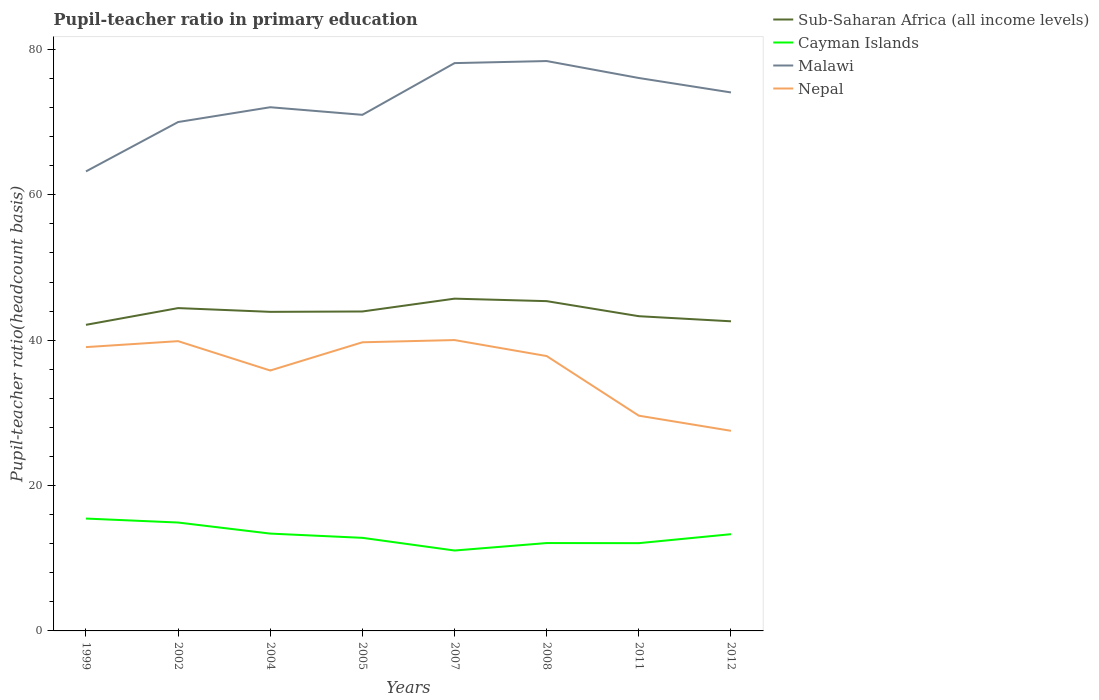Across all years, what is the maximum pupil-teacher ratio in primary education in Cayman Islands?
Give a very brief answer. 11.06. What is the total pupil-teacher ratio in primary education in Cayman Islands in the graph?
Give a very brief answer. -1.22. What is the difference between the highest and the second highest pupil-teacher ratio in primary education in Malawi?
Your answer should be compact. 15.18. How many years are there in the graph?
Keep it short and to the point. 8. What is the difference between two consecutive major ticks on the Y-axis?
Give a very brief answer. 20. Does the graph contain grids?
Make the answer very short. No. Where does the legend appear in the graph?
Give a very brief answer. Top right. What is the title of the graph?
Offer a very short reply. Pupil-teacher ratio in primary education. What is the label or title of the Y-axis?
Your answer should be compact. Pupil-teacher ratio(headcount basis). What is the Pupil-teacher ratio(headcount basis) in Sub-Saharan Africa (all income levels) in 1999?
Give a very brief answer. 42.11. What is the Pupil-teacher ratio(headcount basis) of Cayman Islands in 1999?
Make the answer very short. 15.46. What is the Pupil-teacher ratio(headcount basis) in Malawi in 1999?
Offer a terse response. 63.22. What is the Pupil-teacher ratio(headcount basis) in Nepal in 1999?
Offer a very short reply. 39.05. What is the Pupil-teacher ratio(headcount basis) of Sub-Saharan Africa (all income levels) in 2002?
Offer a terse response. 44.42. What is the Pupil-teacher ratio(headcount basis) of Cayman Islands in 2002?
Offer a very short reply. 14.91. What is the Pupil-teacher ratio(headcount basis) of Malawi in 2002?
Offer a terse response. 70.01. What is the Pupil-teacher ratio(headcount basis) of Nepal in 2002?
Your response must be concise. 39.87. What is the Pupil-teacher ratio(headcount basis) of Sub-Saharan Africa (all income levels) in 2004?
Provide a short and direct response. 43.9. What is the Pupil-teacher ratio(headcount basis) of Cayman Islands in 2004?
Offer a terse response. 13.39. What is the Pupil-teacher ratio(headcount basis) in Malawi in 2004?
Offer a terse response. 72.05. What is the Pupil-teacher ratio(headcount basis) in Nepal in 2004?
Your answer should be compact. 35.83. What is the Pupil-teacher ratio(headcount basis) of Sub-Saharan Africa (all income levels) in 2005?
Give a very brief answer. 43.95. What is the Pupil-teacher ratio(headcount basis) of Cayman Islands in 2005?
Offer a terse response. 12.81. What is the Pupil-teacher ratio(headcount basis) of Malawi in 2005?
Your answer should be very brief. 71.01. What is the Pupil-teacher ratio(headcount basis) of Nepal in 2005?
Provide a succinct answer. 39.71. What is the Pupil-teacher ratio(headcount basis) in Sub-Saharan Africa (all income levels) in 2007?
Offer a very short reply. 45.72. What is the Pupil-teacher ratio(headcount basis) in Cayman Islands in 2007?
Provide a succinct answer. 11.06. What is the Pupil-teacher ratio(headcount basis) of Malawi in 2007?
Give a very brief answer. 78.12. What is the Pupil-teacher ratio(headcount basis) in Nepal in 2007?
Give a very brief answer. 40.02. What is the Pupil-teacher ratio(headcount basis) of Sub-Saharan Africa (all income levels) in 2008?
Your answer should be compact. 45.37. What is the Pupil-teacher ratio(headcount basis) in Cayman Islands in 2008?
Keep it short and to the point. 12.09. What is the Pupil-teacher ratio(headcount basis) of Malawi in 2008?
Your answer should be compact. 78.41. What is the Pupil-teacher ratio(headcount basis) of Nepal in 2008?
Offer a terse response. 37.82. What is the Pupil-teacher ratio(headcount basis) of Sub-Saharan Africa (all income levels) in 2011?
Your answer should be very brief. 43.3. What is the Pupil-teacher ratio(headcount basis) in Cayman Islands in 2011?
Keep it short and to the point. 12.08. What is the Pupil-teacher ratio(headcount basis) of Malawi in 2011?
Your answer should be very brief. 76.07. What is the Pupil-teacher ratio(headcount basis) in Nepal in 2011?
Offer a terse response. 29.61. What is the Pupil-teacher ratio(headcount basis) of Sub-Saharan Africa (all income levels) in 2012?
Your answer should be very brief. 42.6. What is the Pupil-teacher ratio(headcount basis) of Cayman Islands in 2012?
Your answer should be compact. 13.31. What is the Pupil-teacher ratio(headcount basis) in Malawi in 2012?
Your answer should be very brief. 74.09. What is the Pupil-teacher ratio(headcount basis) of Nepal in 2012?
Make the answer very short. 27.53. Across all years, what is the maximum Pupil-teacher ratio(headcount basis) in Sub-Saharan Africa (all income levels)?
Ensure brevity in your answer.  45.72. Across all years, what is the maximum Pupil-teacher ratio(headcount basis) of Cayman Islands?
Offer a very short reply. 15.46. Across all years, what is the maximum Pupil-teacher ratio(headcount basis) of Malawi?
Offer a very short reply. 78.41. Across all years, what is the maximum Pupil-teacher ratio(headcount basis) in Nepal?
Keep it short and to the point. 40.02. Across all years, what is the minimum Pupil-teacher ratio(headcount basis) of Sub-Saharan Africa (all income levels)?
Provide a short and direct response. 42.11. Across all years, what is the minimum Pupil-teacher ratio(headcount basis) in Cayman Islands?
Offer a terse response. 11.06. Across all years, what is the minimum Pupil-teacher ratio(headcount basis) of Malawi?
Your response must be concise. 63.22. Across all years, what is the minimum Pupil-teacher ratio(headcount basis) of Nepal?
Your answer should be very brief. 27.53. What is the total Pupil-teacher ratio(headcount basis) in Sub-Saharan Africa (all income levels) in the graph?
Offer a very short reply. 351.37. What is the total Pupil-teacher ratio(headcount basis) of Cayman Islands in the graph?
Ensure brevity in your answer.  105.11. What is the total Pupil-teacher ratio(headcount basis) in Malawi in the graph?
Offer a very short reply. 582.98. What is the total Pupil-teacher ratio(headcount basis) of Nepal in the graph?
Your answer should be compact. 289.44. What is the difference between the Pupil-teacher ratio(headcount basis) in Sub-Saharan Africa (all income levels) in 1999 and that in 2002?
Your answer should be very brief. -2.3. What is the difference between the Pupil-teacher ratio(headcount basis) of Cayman Islands in 1999 and that in 2002?
Keep it short and to the point. 0.55. What is the difference between the Pupil-teacher ratio(headcount basis) in Malawi in 1999 and that in 2002?
Give a very brief answer. -6.79. What is the difference between the Pupil-teacher ratio(headcount basis) of Nepal in 1999 and that in 2002?
Make the answer very short. -0.82. What is the difference between the Pupil-teacher ratio(headcount basis) in Sub-Saharan Africa (all income levels) in 1999 and that in 2004?
Ensure brevity in your answer.  -1.79. What is the difference between the Pupil-teacher ratio(headcount basis) of Cayman Islands in 1999 and that in 2004?
Keep it short and to the point. 2.07. What is the difference between the Pupil-teacher ratio(headcount basis) in Malawi in 1999 and that in 2004?
Offer a very short reply. -8.83. What is the difference between the Pupil-teacher ratio(headcount basis) in Nepal in 1999 and that in 2004?
Your answer should be very brief. 3.22. What is the difference between the Pupil-teacher ratio(headcount basis) of Sub-Saharan Africa (all income levels) in 1999 and that in 2005?
Make the answer very short. -1.84. What is the difference between the Pupil-teacher ratio(headcount basis) in Cayman Islands in 1999 and that in 2005?
Ensure brevity in your answer.  2.65. What is the difference between the Pupil-teacher ratio(headcount basis) in Malawi in 1999 and that in 2005?
Give a very brief answer. -7.79. What is the difference between the Pupil-teacher ratio(headcount basis) in Nepal in 1999 and that in 2005?
Provide a short and direct response. -0.66. What is the difference between the Pupil-teacher ratio(headcount basis) of Sub-Saharan Africa (all income levels) in 1999 and that in 2007?
Your response must be concise. -3.6. What is the difference between the Pupil-teacher ratio(headcount basis) of Cayman Islands in 1999 and that in 2007?
Provide a short and direct response. 4.4. What is the difference between the Pupil-teacher ratio(headcount basis) of Malawi in 1999 and that in 2007?
Provide a succinct answer. -14.9. What is the difference between the Pupil-teacher ratio(headcount basis) of Nepal in 1999 and that in 2007?
Your answer should be very brief. -0.97. What is the difference between the Pupil-teacher ratio(headcount basis) of Sub-Saharan Africa (all income levels) in 1999 and that in 2008?
Offer a very short reply. -3.26. What is the difference between the Pupil-teacher ratio(headcount basis) of Cayman Islands in 1999 and that in 2008?
Offer a terse response. 3.37. What is the difference between the Pupil-teacher ratio(headcount basis) of Malawi in 1999 and that in 2008?
Your response must be concise. -15.18. What is the difference between the Pupil-teacher ratio(headcount basis) of Nepal in 1999 and that in 2008?
Offer a terse response. 1.23. What is the difference between the Pupil-teacher ratio(headcount basis) of Sub-Saharan Africa (all income levels) in 1999 and that in 2011?
Your response must be concise. -1.19. What is the difference between the Pupil-teacher ratio(headcount basis) of Cayman Islands in 1999 and that in 2011?
Offer a terse response. 3.38. What is the difference between the Pupil-teacher ratio(headcount basis) in Malawi in 1999 and that in 2011?
Give a very brief answer. -12.85. What is the difference between the Pupil-teacher ratio(headcount basis) in Nepal in 1999 and that in 2011?
Provide a succinct answer. 9.43. What is the difference between the Pupil-teacher ratio(headcount basis) in Sub-Saharan Africa (all income levels) in 1999 and that in 2012?
Offer a very short reply. -0.48. What is the difference between the Pupil-teacher ratio(headcount basis) in Cayman Islands in 1999 and that in 2012?
Provide a short and direct response. 2.15. What is the difference between the Pupil-teacher ratio(headcount basis) of Malawi in 1999 and that in 2012?
Keep it short and to the point. -10.86. What is the difference between the Pupil-teacher ratio(headcount basis) of Nepal in 1999 and that in 2012?
Give a very brief answer. 11.52. What is the difference between the Pupil-teacher ratio(headcount basis) of Sub-Saharan Africa (all income levels) in 2002 and that in 2004?
Your response must be concise. 0.52. What is the difference between the Pupil-teacher ratio(headcount basis) in Cayman Islands in 2002 and that in 2004?
Provide a short and direct response. 1.52. What is the difference between the Pupil-teacher ratio(headcount basis) of Malawi in 2002 and that in 2004?
Offer a very short reply. -2.04. What is the difference between the Pupil-teacher ratio(headcount basis) in Nepal in 2002 and that in 2004?
Provide a succinct answer. 4.04. What is the difference between the Pupil-teacher ratio(headcount basis) of Sub-Saharan Africa (all income levels) in 2002 and that in 2005?
Ensure brevity in your answer.  0.47. What is the difference between the Pupil-teacher ratio(headcount basis) of Cayman Islands in 2002 and that in 2005?
Your answer should be compact. 2.11. What is the difference between the Pupil-teacher ratio(headcount basis) of Malawi in 2002 and that in 2005?
Offer a terse response. -0.99. What is the difference between the Pupil-teacher ratio(headcount basis) of Nepal in 2002 and that in 2005?
Keep it short and to the point. 0.16. What is the difference between the Pupil-teacher ratio(headcount basis) of Sub-Saharan Africa (all income levels) in 2002 and that in 2007?
Ensure brevity in your answer.  -1.3. What is the difference between the Pupil-teacher ratio(headcount basis) of Cayman Islands in 2002 and that in 2007?
Your answer should be very brief. 3.85. What is the difference between the Pupil-teacher ratio(headcount basis) of Malawi in 2002 and that in 2007?
Your answer should be compact. -8.11. What is the difference between the Pupil-teacher ratio(headcount basis) of Nepal in 2002 and that in 2007?
Make the answer very short. -0.15. What is the difference between the Pupil-teacher ratio(headcount basis) in Sub-Saharan Africa (all income levels) in 2002 and that in 2008?
Your answer should be compact. -0.96. What is the difference between the Pupil-teacher ratio(headcount basis) in Cayman Islands in 2002 and that in 2008?
Ensure brevity in your answer.  2.82. What is the difference between the Pupil-teacher ratio(headcount basis) of Malawi in 2002 and that in 2008?
Your response must be concise. -8.39. What is the difference between the Pupil-teacher ratio(headcount basis) in Nepal in 2002 and that in 2008?
Your answer should be compact. 2.05. What is the difference between the Pupil-teacher ratio(headcount basis) in Sub-Saharan Africa (all income levels) in 2002 and that in 2011?
Make the answer very short. 1.12. What is the difference between the Pupil-teacher ratio(headcount basis) in Cayman Islands in 2002 and that in 2011?
Offer a very short reply. 2.84. What is the difference between the Pupil-teacher ratio(headcount basis) of Malawi in 2002 and that in 2011?
Your answer should be very brief. -6.06. What is the difference between the Pupil-teacher ratio(headcount basis) of Nepal in 2002 and that in 2011?
Offer a terse response. 10.25. What is the difference between the Pupil-teacher ratio(headcount basis) in Sub-Saharan Africa (all income levels) in 2002 and that in 2012?
Your answer should be very brief. 1.82. What is the difference between the Pupil-teacher ratio(headcount basis) in Cayman Islands in 2002 and that in 2012?
Your response must be concise. 1.6. What is the difference between the Pupil-teacher ratio(headcount basis) of Malawi in 2002 and that in 2012?
Keep it short and to the point. -4.07. What is the difference between the Pupil-teacher ratio(headcount basis) in Nepal in 2002 and that in 2012?
Your answer should be very brief. 12.34. What is the difference between the Pupil-teacher ratio(headcount basis) of Sub-Saharan Africa (all income levels) in 2004 and that in 2005?
Your answer should be very brief. -0.05. What is the difference between the Pupil-teacher ratio(headcount basis) of Cayman Islands in 2004 and that in 2005?
Provide a succinct answer. 0.58. What is the difference between the Pupil-teacher ratio(headcount basis) of Malawi in 2004 and that in 2005?
Provide a short and direct response. 1.04. What is the difference between the Pupil-teacher ratio(headcount basis) in Nepal in 2004 and that in 2005?
Offer a terse response. -3.88. What is the difference between the Pupil-teacher ratio(headcount basis) in Sub-Saharan Africa (all income levels) in 2004 and that in 2007?
Ensure brevity in your answer.  -1.81. What is the difference between the Pupil-teacher ratio(headcount basis) of Cayman Islands in 2004 and that in 2007?
Your response must be concise. 2.33. What is the difference between the Pupil-teacher ratio(headcount basis) of Malawi in 2004 and that in 2007?
Provide a short and direct response. -6.07. What is the difference between the Pupil-teacher ratio(headcount basis) of Nepal in 2004 and that in 2007?
Your response must be concise. -4.19. What is the difference between the Pupil-teacher ratio(headcount basis) in Sub-Saharan Africa (all income levels) in 2004 and that in 2008?
Ensure brevity in your answer.  -1.47. What is the difference between the Pupil-teacher ratio(headcount basis) of Cayman Islands in 2004 and that in 2008?
Provide a succinct answer. 1.3. What is the difference between the Pupil-teacher ratio(headcount basis) in Malawi in 2004 and that in 2008?
Offer a terse response. -6.35. What is the difference between the Pupil-teacher ratio(headcount basis) in Nepal in 2004 and that in 2008?
Make the answer very short. -1.99. What is the difference between the Pupil-teacher ratio(headcount basis) in Sub-Saharan Africa (all income levels) in 2004 and that in 2011?
Your answer should be very brief. 0.6. What is the difference between the Pupil-teacher ratio(headcount basis) in Cayman Islands in 2004 and that in 2011?
Make the answer very short. 1.31. What is the difference between the Pupil-teacher ratio(headcount basis) in Malawi in 2004 and that in 2011?
Offer a very short reply. -4.02. What is the difference between the Pupil-teacher ratio(headcount basis) of Nepal in 2004 and that in 2011?
Keep it short and to the point. 6.21. What is the difference between the Pupil-teacher ratio(headcount basis) of Sub-Saharan Africa (all income levels) in 2004 and that in 2012?
Your answer should be compact. 1.3. What is the difference between the Pupil-teacher ratio(headcount basis) in Cayman Islands in 2004 and that in 2012?
Provide a short and direct response. 0.08. What is the difference between the Pupil-teacher ratio(headcount basis) in Malawi in 2004 and that in 2012?
Your response must be concise. -2.03. What is the difference between the Pupil-teacher ratio(headcount basis) of Nepal in 2004 and that in 2012?
Give a very brief answer. 8.3. What is the difference between the Pupil-teacher ratio(headcount basis) in Sub-Saharan Africa (all income levels) in 2005 and that in 2007?
Make the answer very short. -1.76. What is the difference between the Pupil-teacher ratio(headcount basis) in Cayman Islands in 2005 and that in 2007?
Offer a very short reply. 1.74. What is the difference between the Pupil-teacher ratio(headcount basis) in Malawi in 2005 and that in 2007?
Your answer should be very brief. -7.12. What is the difference between the Pupil-teacher ratio(headcount basis) in Nepal in 2005 and that in 2007?
Make the answer very short. -0.31. What is the difference between the Pupil-teacher ratio(headcount basis) in Sub-Saharan Africa (all income levels) in 2005 and that in 2008?
Your response must be concise. -1.42. What is the difference between the Pupil-teacher ratio(headcount basis) in Cayman Islands in 2005 and that in 2008?
Keep it short and to the point. 0.72. What is the difference between the Pupil-teacher ratio(headcount basis) of Malawi in 2005 and that in 2008?
Keep it short and to the point. -7.4. What is the difference between the Pupil-teacher ratio(headcount basis) of Nepal in 2005 and that in 2008?
Offer a terse response. 1.9. What is the difference between the Pupil-teacher ratio(headcount basis) in Sub-Saharan Africa (all income levels) in 2005 and that in 2011?
Offer a terse response. 0.65. What is the difference between the Pupil-teacher ratio(headcount basis) of Cayman Islands in 2005 and that in 2011?
Ensure brevity in your answer.  0.73. What is the difference between the Pupil-teacher ratio(headcount basis) in Malawi in 2005 and that in 2011?
Your response must be concise. -5.07. What is the difference between the Pupil-teacher ratio(headcount basis) of Nepal in 2005 and that in 2011?
Your answer should be very brief. 10.1. What is the difference between the Pupil-teacher ratio(headcount basis) of Sub-Saharan Africa (all income levels) in 2005 and that in 2012?
Give a very brief answer. 1.35. What is the difference between the Pupil-teacher ratio(headcount basis) of Cayman Islands in 2005 and that in 2012?
Your answer should be very brief. -0.5. What is the difference between the Pupil-teacher ratio(headcount basis) in Malawi in 2005 and that in 2012?
Make the answer very short. -3.08. What is the difference between the Pupil-teacher ratio(headcount basis) in Nepal in 2005 and that in 2012?
Offer a terse response. 12.18. What is the difference between the Pupil-teacher ratio(headcount basis) of Sub-Saharan Africa (all income levels) in 2007 and that in 2008?
Provide a succinct answer. 0.34. What is the difference between the Pupil-teacher ratio(headcount basis) in Cayman Islands in 2007 and that in 2008?
Offer a terse response. -1.03. What is the difference between the Pupil-teacher ratio(headcount basis) in Malawi in 2007 and that in 2008?
Ensure brevity in your answer.  -0.28. What is the difference between the Pupil-teacher ratio(headcount basis) in Nepal in 2007 and that in 2008?
Give a very brief answer. 2.2. What is the difference between the Pupil-teacher ratio(headcount basis) in Sub-Saharan Africa (all income levels) in 2007 and that in 2011?
Provide a short and direct response. 2.41. What is the difference between the Pupil-teacher ratio(headcount basis) of Cayman Islands in 2007 and that in 2011?
Offer a very short reply. -1.01. What is the difference between the Pupil-teacher ratio(headcount basis) in Malawi in 2007 and that in 2011?
Keep it short and to the point. 2.05. What is the difference between the Pupil-teacher ratio(headcount basis) in Nepal in 2007 and that in 2011?
Provide a succinct answer. 10.4. What is the difference between the Pupil-teacher ratio(headcount basis) in Sub-Saharan Africa (all income levels) in 2007 and that in 2012?
Give a very brief answer. 3.12. What is the difference between the Pupil-teacher ratio(headcount basis) of Cayman Islands in 2007 and that in 2012?
Make the answer very short. -2.25. What is the difference between the Pupil-teacher ratio(headcount basis) of Malawi in 2007 and that in 2012?
Keep it short and to the point. 4.04. What is the difference between the Pupil-teacher ratio(headcount basis) in Nepal in 2007 and that in 2012?
Your answer should be very brief. 12.48. What is the difference between the Pupil-teacher ratio(headcount basis) in Sub-Saharan Africa (all income levels) in 2008 and that in 2011?
Keep it short and to the point. 2.07. What is the difference between the Pupil-teacher ratio(headcount basis) of Cayman Islands in 2008 and that in 2011?
Ensure brevity in your answer.  0.01. What is the difference between the Pupil-teacher ratio(headcount basis) in Malawi in 2008 and that in 2011?
Your answer should be very brief. 2.33. What is the difference between the Pupil-teacher ratio(headcount basis) of Nepal in 2008 and that in 2011?
Offer a very short reply. 8.2. What is the difference between the Pupil-teacher ratio(headcount basis) of Sub-Saharan Africa (all income levels) in 2008 and that in 2012?
Your answer should be very brief. 2.77. What is the difference between the Pupil-teacher ratio(headcount basis) of Cayman Islands in 2008 and that in 2012?
Make the answer very short. -1.22. What is the difference between the Pupil-teacher ratio(headcount basis) of Malawi in 2008 and that in 2012?
Your response must be concise. 4.32. What is the difference between the Pupil-teacher ratio(headcount basis) of Nepal in 2008 and that in 2012?
Your answer should be compact. 10.28. What is the difference between the Pupil-teacher ratio(headcount basis) of Sub-Saharan Africa (all income levels) in 2011 and that in 2012?
Give a very brief answer. 0.7. What is the difference between the Pupil-teacher ratio(headcount basis) in Cayman Islands in 2011 and that in 2012?
Your answer should be compact. -1.23. What is the difference between the Pupil-teacher ratio(headcount basis) of Malawi in 2011 and that in 2012?
Keep it short and to the point. 1.99. What is the difference between the Pupil-teacher ratio(headcount basis) of Nepal in 2011 and that in 2012?
Make the answer very short. 2.08. What is the difference between the Pupil-teacher ratio(headcount basis) of Sub-Saharan Africa (all income levels) in 1999 and the Pupil-teacher ratio(headcount basis) of Cayman Islands in 2002?
Keep it short and to the point. 27.2. What is the difference between the Pupil-teacher ratio(headcount basis) in Sub-Saharan Africa (all income levels) in 1999 and the Pupil-teacher ratio(headcount basis) in Malawi in 2002?
Make the answer very short. -27.9. What is the difference between the Pupil-teacher ratio(headcount basis) in Sub-Saharan Africa (all income levels) in 1999 and the Pupil-teacher ratio(headcount basis) in Nepal in 2002?
Provide a short and direct response. 2.25. What is the difference between the Pupil-teacher ratio(headcount basis) in Cayman Islands in 1999 and the Pupil-teacher ratio(headcount basis) in Malawi in 2002?
Offer a very short reply. -54.56. What is the difference between the Pupil-teacher ratio(headcount basis) in Cayman Islands in 1999 and the Pupil-teacher ratio(headcount basis) in Nepal in 2002?
Ensure brevity in your answer.  -24.41. What is the difference between the Pupil-teacher ratio(headcount basis) in Malawi in 1999 and the Pupil-teacher ratio(headcount basis) in Nepal in 2002?
Provide a short and direct response. 23.35. What is the difference between the Pupil-teacher ratio(headcount basis) of Sub-Saharan Africa (all income levels) in 1999 and the Pupil-teacher ratio(headcount basis) of Cayman Islands in 2004?
Keep it short and to the point. 28.72. What is the difference between the Pupil-teacher ratio(headcount basis) of Sub-Saharan Africa (all income levels) in 1999 and the Pupil-teacher ratio(headcount basis) of Malawi in 2004?
Your answer should be compact. -29.94. What is the difference between the Pupil-teacher ratio(headcount basis) of Sub-Saharan Africa (all income levels) in 1999 and the Pupil-teacher ratio(headcount basis) of Nepal in 2004?
Ensure brevity in your answer.  6.29. What is the difference between the Pupil-teacher ratio(headcount basis) in Cayman Islands in 1999 and the Pupil-teacher ratio(headcount basis) in Malawi in 2004?
Keep it short and to the point. -56.59. What is the difference between the Pupil-teacher ratio(headcount basis) of Cayman Islands in 1999 and the Pupil-teacher ratio(headcount basis) of Nepal in 2004?
Your answer should be very brief. -20.37. What is the difference between the Pupil-teacher ratio(headcount basis) of Malawi in 1999 and the Pupil-teacher ratio(headcount basis) of Nepal in 2004?
Give a very brief answer. 27.39. What is the difference between the Pupil-teacher ratio(headcount basis) in Sub-Saharan Africa (all income levels) in 1999 and the Pupil-teacher ratio(headcount basis) in Cayman Islands in 2005?
Your response must be concise. 29.31. What is the difference between the Pupil-teacher ratio(headcount basis) of Sub-Saharan Africa (all income levels) in 1999 and the Pupil-teacher ratio(headcount basis) of Malawi in 2005?
Your response must be concise. -28.89. What is the difference between the Pupil-teacher ratio(headcount basis) of Sub-Saharan Africa (all income levels) in 1999 and the Pupil-teacher ratio(headcount basis) of Nepal in 2005?
Provide a succinct answer. 2.4. What is the difference between the Pupil-teacher ratio(headcount basis) of Cayman Islands in 1999 and the Pupil-teacher ratio(headcount basis) of Malawi in 2005?
Offer a terse response. -55.55. What is the difference between the Pupil-teacher ratio(headcount basis) in Cayman Islands in 1999 and the Pupil-teacher ratio(headcount basis) in Nepal in 2005?
Provide a succinct answer. -24.25. What is the difference between the Pupil-teacher ratio(headcount basis) in Malawi in 1999 and the Pupil-teacher ratio(headcount basis) in Nepal in 2005?
Provide a short and direct response. 23.51. What is the difference between the Pupil-teacher ratio(headcount basis) of Sub-Saharan Africa (all income levels) in 1999 and the Pupil-teacher ratio(headcount basis) of Cayman Islands in 2007?
Provide a succinct answer. 31.05. What is the difference between the Pupil-teacher ratio(headcount basis) of Sub-Saharan Africa (all income levels) in 1999 and the Pupil-teacher ratio(headcount basis) of Malawi in 2007?
Give a very brief answer. -36.01. What is the difference between the Pupil-teacher ratio(headcount basis) in Sub-Saharan Africa (all income levels) in 1999 and the Pupil-teacher ratio(headcount basis) in Nepal in 2007?
Keep it short and to the point. 2.1. What is the difference between the Pupil-teacher ratio(headcount basis) in Cayman Islands in 1999 and the Pupil-teacher ratio(headcount basis) in Malawi in 2007?
Your response must be concise. -62.66. What is the difference between the Pupil-teacher ratio(headcount basis) of Cayman Islands in 1999 and the Pupil-teacher ratio(headcount basis) of Nepal in 2007?
Provide a succinct answer. -24.56. What is the difference between the Pupil-teacher ratio(headcount basis) in Malawi in 1999 and the Pupil-teacher ratio(headcount basis) in Nepal in 2007?
Keep it short and to the point. 23.2. What is the difference between the Pupil-teacher ratio(headcount basis) in Sub-Saharan Africa (all income levels) in 1999 and the Pupil-teacher ratio(headcount basis) in Cayman Islands in 2008?
Ensure brevity in your answer.  30.02. What is the difference between the Pupil-teacher ratio(headcount basis) in Sub-Saharan Africa (all income levels) in 1999 and the Pupil-teacher ratio(headcount basis) in Malawi in 2008?
Provide a short and direct response. -36.29. What is the difference between the Pupil-teacher ratio(headcount basis) of Sub-Saharan Africa (all income levels) in 1999 and the Pupil-teacher ratio(headcount basis) of Nepal in 2008?
Provide a short and direct response. 4.3. What is the difference between the Pupil-teacher ratio(headcount basis) in Cayman Islands in 1999 and the Pupil-teacher ratio(headcount basis) in Malawi in 2008?
Your answer should be compact. -62.95. What is the difference between the Pupil-teacher ratio(headcount basis) in Cayman Islands in 1999 and the Pupil-teacher ratio(headcount basis) in Nepal in 2008?
Provide a succinct answer. -22.36. What is the difference between the Pupil-teacher ratio(headcount basis) of Malawi in 1999 and the Pupil-teacher ratio(headcount basis) of Nepal in 2008?
Your answer should be very brief. 25.4. What is the difference between the Pupil-teacher ratio(headcount basis) in Sub-Saharan Africa (all income levels) in 1999 and the Pupil-teacher ratio(headcount basis) in Cayman Islands in 2011?
Your answer should be compact. 30.04. What is the difference between the Pupil-teacher ratio(headcount basis) in Sub-Saharan Africa (all income levels) in 1999 and the Pupil-teacher ratio(headcount basis) in Malawi in 2011?
Provide a succinct answer. -33.96. What is the difference between the Pupil-teacher ratio(headcount basis) of Sub-Saharan Africa (all income levels) in 1999 and the Pupil-teacher ratio(headcount basis) of Nepal in 2011?
Offer a very short reply. 12.5. What is the difference between the Pupil-teacher ratio(headcount basis) in Cayman Islands in 1999 and the Pupil-teacher ratio(headcount basis) in Malawi in 2011?
Provide a short and direct response. -60.61. What is the difference between the Pupil-teacher ratio(headcount basis) in Cayman Islands in 1999 and the Pupil-teacher ratio(headcount basis) in Nepal in 2011?
Ensure brevity in your answer.  -14.15. What is the difference between the Pupil-teacher ratio(headcount basis) in Malawi in 1999 and the Pupil-teacher ratio(headcount basis) in Nepal in 2011?
Your answer should be compact. 33.61. What is the difference between the Pupil-teacher ratio(headcount basis) in Sub-Saharan Africa (all income levels) in 1999 and the Pupil-teacher ratio(headcount basis) in Cayman Islands in 2012?
Offer a very short reply. 28.8. What is the difference between the Pupil-teacher ratio(headcount basis) in Sub-Saharan Africa (all income levels) in 1999 and the Pupil-teacher ratio(headcount basis) in Malawi in 2012?
Offer a terse response. -31.97. What is the difference between the Pupil-teacher ratio(headcount basis) of Sub-Saharan Africa (all income levels) in 1999 and the Pupil-teacher ratio(headcount basis) of Nepal in 2012?
Give a very brief answer. 14.58. What is the difference between the Pupil-teacher ratio(headcount basis) in Cayman Islands in 1999 and the Pupil-teacher ratio(headcount basis) in Malawi in 2012?
Provide a succinct answer. -58.63. What is the difference between the Pupil-teacher ratio(headcount basis) of Cayman Islands in 1999 and the Pupil-teacher ratio(headcount basis) of Nepal in 2012?
Offer a terse response. -12.07. What is the difference between the Pupil-teacher ratio(headcount basis) of Malawi in 1999 and the Pupil-teacher ratio(headcount basis) of Nepal in 2012?
Your response must be concise. 35.69. What is the difference between the Pupil-teacher ratio(headcount basis) of Sub-Saharan Africa (all income levels) in 2002 and the Pupil-teacher ratio(headcount basis) of Cayman Islands in 2004?
Your answer should be compact. 31.03. What is the difference between the Pupil-teacher ratio(headcount basis) in Sub-Saharan Africa (all income levels) in 2002 and the Pupil-teacher ratio(headcount basis) in Malawi in 2004?
Your response must be concise. -27.63. What is the difference between the Pupil-teacher ratio(headcount basis) of Sub-Saharan Africa (all income levels) in 2002 and the Pupil-teacher ratio(headcount basis) of Nepal in 2004?
Ensure brevity in your answer.  8.59. What is the difference between the Pupil-teacher ratio(headcount basis) of Cayman Islands in 2002 and the Pupil-teacher ratio(headcount basis) of Malawi in 2004?
Keep it short and to the point. -57.14. What is the difference between the Pupil-teacher ratio(headcount basis) in Cayman Islands in 2002 and the Pupil-teacher ratio(headcount basis) in Nepal in 2004?
Keep it short and to the point. -20.92. What is the difference between the Pupil-teacher ratio(headcount basis) in Malawi in 2002 and the Pupil-teacher ratio(headcount basis) in Nepal in 2004?
Give a very brief answer. 34.19. What is the difference between the Pupil-teacher ratio(headcount basis) of Sub-Saharan Africa (all income levels) in 2002 and the Pupil-teacher ratio(headcount basis) of Cayman Islands in 2005?
Give a very brief answer. 31.61. What is the difference between the Pupil-teacher ratio(headcount basis) in Sub-Saharan Africa (all income levels) in 2002 and the Pupil-teacher ratio(headcount basis) in Malawi in 2005?
Make the answer very short. -26.59. What is the difference between the Pupil-teacher ratio(headcount basis) in Sub-Saharan Africa (all income levels) in 2002 and the Pupil-teacher ratio(headcount basis) in Nepal in 2005?
Make the answer very short. 4.71. What is the difference between the Pupil-teacher ratio(headcount basis) in Cayman Islands in 2002 and the Pupil-teacher ratio(headcount basis) in Malawi in 2005?
Give a very brief answer. -56.09. What is the difference between the Pupil-teacher ratio(headcount basis) in Cayman Islands in 2002 and the Pupil-teacher ratio(headcount basis) in Nepal in 2005?
Your answer should be compact. -24.8. What is the difference between the Pupil-teacher ratio(headcount basis) of Malawi in 2002 and the Pupil-teacher ratio(headcount basis) of Nepal in 2005?
Keep it short and to the point. 30.3. What is the difference between the Pupil-teacher ratio(headcount basis) of Sub-Saharan Africa (all income levels) in 2002 and the Pupil-teacher ratio(headcount basis) of Cayman Islands in 2007?
Your answer should be very brief. 33.35. What is the difference between the Pupil-teacher ratio(headcount basis) of Sub-Saharan Africa (all income levels) in 2002 and the Pupil-teacher ratio(headcount basis) of Malawi in 2007?
Your answer should be very brief. -33.71. What is the difference between the Pupil-teacher ratio(headcount basis) in Sub-Saharan Africa (all income levels) in 2002 and the Pupil-teacher ratio(headcount basis) in Nepal in 2007?
Your response must be concise. 4.4. What is the difference between the Pupil-teacher ratio(headcount basis) in Cayman Islands in 2002 and the Pupil-teacher ratio(headcount basis) in Malawi in 2007?
Offer a very short reply. -63.21. What is the difference between the Pupil-teacher ratio(headcount basis) of Cayman Islands in 2002 and the Pupil-teacher ratio(headcount basis) of Nepal in 2007?
Ensure brevity in your answer.  -25.11. What is the difference between the Pupil-teacher ratio(headcount basis) in Malawi in 2002 and the Pupil-teacher ratio(headcount basis) in Nepal in 2007?
Give a very brief answer. 30. What is the difference between the Pupil-teacher ratio(headcount basis) of Sub-Saharan Africa (all income levels) in 2002 and the Pupil-teacher ratio(headcount basis) of Cayman Islands in 2008?
Your response must be concise. 32.33. What is the difference between the Pupil-teacher ratio(headcount basis) in Sub-Saharan Africa (all income levels) in 2002 and the Pupil-teacher ratio(headcount basis) in Malawi in 2008?
Your answer should be very brief. -33.99. What is the difference between the Pupil-teacher ratio(headcount basis) of Sub-Saharan Africa (all income levels) in 2002 and the Pupil-teacher ratio(headcount basis) of Nepal in 2008?
Provide a short and direct response. 6.6. What is the difference between the Pupil-teacher ratio(headcount basis) in Cayman Islands in 2002 and the Pupil-teacher ratio(headcount basis) in Malawi in 2008?
Make the answer very short. -63.49. What is the difference between the Pupil-teacher ratio(headcount basis) in Cayman Islands in 2002 and the Pupil-teacher ratio(headcount basis) in Nepal in 2008?
Offer a terse response. -22.9. What is the difference between the Pupil-teacher ratio(headcount basis) in Malawi in 2002 and the Pupil-teacher ratio(headcount basis) in Nepal in 2008?
Keep it short and to the point. 32.2. What is the difference between the Pupil-teacher ratio(headcount basis) in Sub-Saharan Africa (all income levels) in 2002 and the Pupil-teacher ratio(headcount basis) in Cayman Islands in 2011?
Give a very brief answer. 32.34. What is the difference between the Pupil-teacher ratio(headcount basis) of Sub-Saharan Africa (all income levels) in 2002 and the Pupil-teacher ratio(headcount basis) of Malawi in 2011?
Provide a succinct answer. -31.66. What is the difference between the Pupil-teacher ratio(headcount basis) of Sub-Saharan Africa (all income levels) in 2002 and the Pupil-teacher ratio(headcount basis) of Nepal in 2011?
Provide a succinct answer. 14.8. What is the difference between the Pupil-teacher ratio(headcount basis) of Cayman Islands in 2002 and the Pupil-teacher ratio(headcount basis) of Malawi in 2011?
Make the answer very short. -61.16. What is the difference between the Pupil-teacher ratio(headcount basis) of Cayman Islands in 2002 and the Pupil-teacher ratio(headcount basis) of Nepal in 2011?
Offer a very short reply. -14.7. What is the difference between the Pupil-teacher ratio(headcount basis) of Malawi in 2002 and the Pupil-teacher ratio(headcount basis) of Nepal in 2011?
Provide a succinct answer. 40.4. What is the difference between the Pupil-teacher ratio(headcount basis) of Sub-Saharan Africa (all income levels) in 2002 and the Pupil-teacher ratio(headcount basis) of Cayman Islands in 2012?
Your answer should be very brief. 31.11. What is the difference between the Pupil-teacher ratio(headcount basis) of Sub-Saharan Africa (all income levels) in 2002 and the Pupil-teacher ratio(headcount basis) of Malawi in 2012?
Give a very brief answer. -29.67. What is the difference between the Pupil-teacher ratio(headcount basis) of Sub-Saharan Africa (all income levels) in 2002 and the Pupil-teacher ratio(headcount basis) of Nepal in 2012?
Make the answer very short. 16.88. What is the difference between the Pupil-teacher ratio(headcount basis) of Cayman Islands in 2002 and the Pupil-teacher ratio(headcount basis) of Malawi in 2012?
Ensure brevity in your answer.  -59.17. What is the difference between the Pupil-teacher ratio(headcount basis) of Cayman Islands in 2002 and the Pupil-teacher ratio(headcount basis) of Nepal in 2012?
Provide a succinct answer. -12.62. What is the difference between the Pupil-teacher ratio(headcount basis) of Malawi in 2002 and the Pupil-teacher ratio(headcount basis) of Nepal in 2012?
Provide a succinct answer. 42.48. What is the difference between the Pupil-teacher ratio(headcount basis) of Sub-Saharan Africa (all income levels) in 2004 and the Pupil-teacher ratio(headcount basis) of Cayman Islands in 2005?
Provide a short and direct response. 31.09. What is the difference between the Pupil-teacher ratio(headcount basis) of Sub-Saharan Africa (all income levels) in 2004 and the Pupil-teacher ratio(headcount basis) of Malawi in 2005?
Give a very brief answer. -27.11. What is the difference between the Pupil-teacher ratio(headcount basis) of Sub-Saharan Africa (all income levels) in 2004 and the Pupil-teacher ratio(headcount basis) of Nepal in 2005?
Your answer should be compact. 4.19. What is the difference between the Pupil-teacher ratio(headcount basis) of Cayman Islands in 2004 and the Pupil-teacher ratio(headcount basis) of Malawi in 2005?
Ensure brevity in your answer.  -57.62. What is the difference between the Pupil-teacher ratio(headcount basis) of Cayman Islands in 2004 and the Pupil-teacher ratio(headcount basis) of Nepal in 2005?
Your response must be concise. -26.32. What is the difference between the Pupil-teacher ratio(headcount basis) of Malawi in 2004 and the Pupil-teacher ratio(headcount basis) of Nepal in 2005?
Keep it short and to the point. 32.34. What is the difference between the Pupil-teacher ratio(headcount basis) in Sub-Saharan Africa (all income levels) in 2004 and the Pupil-teacher ratio(headcount basis) in Cayman Islands in 2007?
Give a very brief answer. 32.84. What is the difference between the Pupil-teacher ratio(headcount basis) of Sub-Saharan Africa (all income levels) in 2004 and the Pupil-teacher ratio(headcount basis) of Malawi in 2007?
Make the answer very short. -34.22. What is the difference between the Pupil-teacher ratio(headcount basis) of Sub-Saharan Africa (all income levels) in 2004 and the Pupil-teacher ratio(headcount basis) of Nepal in 2007?
Make the answer very short. 3.88. What is the difference between the Pupil-teacher ratio(headcount basis) in Cayman Islands in 2004 and the Pupil-teacher ratio(headcount basis) in Malawi in 2007?
Offer a very short reply. -64.73. What is the difference between the Pupil-teacher ratio(headcount basis) in Cayman Islands in 2004 and the Pupil-teacher ratio(headcount basis) in Nepal in 2007?
Make the answer very short. -26.63. What is the difference between the Pupil-teacher ratio(headcount basis) in Malawi in 2004 and the Pupil-teacher ratio(headcount basis) in Nepal in 2007?
Keep it short and to the point. 32.03. What is the difference between the Pupil-teacher ratio(headcount basis) in Sub-Saharan Africa (all income levels) in 2004 and the Pupil-teacher ratio(headcount basis) in Cayman Islands in 2008?
Offer a very short reply. 31.81. What is the difference between the Pupil-teacher ratio(headcount basis) in Sub-Saharan Africa (all income levels) in 2004 and the Pupil-teacher ratio(headcount basis) in Malawi in 2008?
Give a very brief answer. -34.5. What is the difference between the Pupil-teacher ratio(headcount basis) in Sub-Saharan Africa (all income levels) in 2004 and the Pupil-teacher ratio(headcount basis) in Nepal in 2008?
Your answer should be very brief. 6.08. What is the difference between the Pupil-teacher ratio(headcount basis) of Cayman Islands in 2004 and the Pupil-teacher ratio(headcount basis) of Malawi in 2008?
Your answer should be very brief. -65.02. What is the difference between the Pupil-teacher ratio(headcount basis) in Cayman Islands in 2004 and the Pupil-teacher ratio(headcount basis) in Nepal in 2008?
Keep it short and to the point. -24.43. What is the difference between the Pupil-teacher ratio(headcount basis) of Malawi in 2004 and the Pupil-teacher ratio(headcount basis) of Nepal in 2008?
Offer a very short reply. 34.23. What is the difference between the Pupil-teacher ratio(headcount basis) of Sub-Saharan Africa (all income levels) in 2004 and the Pupil-teacher ratio(headcount basis) of Cayman Islands in 2011?
Give a very brief answer. 31.83. What is the difference between the Pupil-teacher ratio(headcount basis) of Sub-Saharan Africa (all income levels) in 2004 and the Pupil-teacher ratio(headcount basis) of Malawi in 2011?
Provide a short and direct response. -32.17. What is the difference between the Pupil-teacher ratio(headcount basis) of Sub-Saharan Africa (all income levels) in 2004 and the Pupil-teacher ratio(headcount basis) of Nepal in 2011?
Provide a short and direct response. 14.29. What is the difference between the Pupil-teacher ratio(headcount basis) in Cayman Islands in 2004 and the Pupil-teacher ratio(headcount basis) in Malawi in 2011?
Provide a short and direct response. -62.68. What is the difference between the Pupil-teacher ratio(headcount basis) in Cayman Islands in 2004 and the Pupil-teacher ratio(headcount basis) in Nepal in 2011?
Your answer should be compact. -16.22. What is the difference between the Pupil-teacher ratio(headcount basis) in Malawi in 2004 and the Pupil-teacher ratio(headcount basis) in Nepal in 2011?
Offer a very short reply. 42.44. What is the difference between the Pupil-teacher ratio(headcount basis) of Sub-Saharan Africa (all income levels) in 2004 and the Pupil-teacher ratio(headcount basis) of Cayman Islands in 2012?
Provide a succinct answer. 30.59. What is the difference between the Pupil-teacher ratio(headcount basis) in Sub-Saharan Africa (all income levels) in 2004 and the Pupil-teacher ratio(headcount basis) in Malawi in 2012?
Provide a succinct answer. -30.19. What is the difference between the Pupil-teacher ratio(headcount basis) in Sub-Saharan Africa (all income levels) in 2004 and the Pupil-teacher ratio(headcount basis) in Nepal in 2012?
Your response must be concise. 16.37. What is the difference between the Pupil-teacher ratio(headcount basis) of Cayman Islands in 2004 and the Pupil-teacher ratio(headcount basis) of Malawi in 2012?
Make the answer very short. -60.7. What is the difference between the Pupil-teacher ratio(headcount basis) of Cayman Islands in 2004 and the Pupil-teacher ratio(headcount basis) of Nepal in 2012?
Offer a terse response. -14.14. What is the difference between the Pupil-teacher ratio(headcount basis) of Malawi in 2004 and the Pupil-teacher ratio(headcount basis) of Nepal in 2012?
Offer a terse response. 44.52. What is the difference between the Pupil-teacher ratio(headcount basis) in Sub-Saharan Africa (all income levels) in 2005 and the Pupil-teacher ratio(headcount basis) in Cayman Islands in 2007?
Offer a terse response. 32.89. What is the difference between the Pupil-teacher ratio(headcount basis) in Sub-Saharan Africa (all income levels) in 2005 and the Pupil-teacher ratio(headcount basis) in Malawi in 2007?
Offer a very short reply. -34.17. What is the difference between the Pupil-teacher ratio(headcount basis) in Sub-Saharan Africa (all income levels) in 2005 and the Pupil-teacher ratio(headcount basis) in Nepal in 2007?
Provide a short and direct response. 3.93. What is the difference between the Pupil-teacher ratio(headcount basis) in Cayman Islands in 2005 and the Pupil-teacher ratio(headcount basis) in Malawi in 2007?
Provide a succinct answer. -65.32. What is the difference between the Pupil-teacher ratio(headcount basis) of Cayman Islands in 2005 and the Pupil-teacher ratio(headcount basis) of Nepal in 2007?
Provide a short and direct response. -27.21. What is the difference between the Pupil-teacher ratio(headcount basis) in Malawi in 2005 and the Pupil-teacher ratio(headcount basis) in Nepal in 2007?
Provide a succinct answer. 30.99. What is the difference between the Pupil-teacher ratio(headcount basis) of Sub-Saharan Africa (all income levels) in 2005 and the Pupil-teacher ratio(headcount basis) of Cayman Islands in 2008?
Offer a terse response. 31.86. What is the difference between the Pupil-teacher ratio(headcount basis) in Sub-Saharan Africa (all income levels) in 2005 and the Pupil-teacher ratio(headcount basis) in Malawi in 2008?
Offer a terse response. -34.46. What is the difference between the Pupil-teacher ratio(headcount basis) in Sub-Saharan Africa (all income levels) in 2005 and the Pupil-teacher ratio(headcount basis) in Nepal in 2008?
Offer a terse response. 6.13. What is the difference between the Pupil-teacher ratio(headcount basis) of Cayman Islands in 2005 and the Pupil-teacher ratio(headcount basis) of Malawi in 2008?
Your answer should be compact. -65.6. What is the difference between the Pupil-teacher ratio(headcount basis) of Cayman Islands in 2005 and the Pupil-teacher ratio(headcount basis) of Nepal in 2008?
Provide a succinct answer. -25.01. What is the difference between the Pupil-teacher ratio(headcount basis) in Malawi in 2005 and the Pupil-teacher ratio(headcount basis) in Nepal in 2008?
Offer a very short reply. 33.19. What is the difference between the Pupil-teacher ratio(headcount basis) of Sub-Saharan Africa (all income levels) in 2005 and the Pupil-teacher ratio(headcount basis) of Cayman Islands in 2011?
Provide a succinct answer. 31.87. What is the difference between the Pupil-teacher ratio(headcount basis) of Sub-Saharan Africa (all income levels) in 2005 and the Pupil-teacher ratio(headcount basis) of Malawi in 2011?
Your answer should be compact. -32.12. What is the difference between the Pupil-teacher ratio(headcount basis) in Sub-Saharan Africa (all income levels) in 2005 and the Pupil-teacher ratio(headcount basis) in Nepal in 2011?
Your answer should be very brief. 14.34. What is the difference between the Pupil-teacher ratio(headcount basis) of Cayman Islands in 2005 and the Pupil-teacher ratio(headcount basis) of Malawi in 2011?
Your answer should be compact. -63.27. What is the difference between the Pupil-teacher ratio(headcount basis) of Cayman Islands in 2005 and the Pupil-teacher ratio(headcount basis) of Nepal in 2011?
Offer a terse response. -16.81. What is the difference between the Pupil-teacher ratio(headcount basis) in Malawi in 2005 and the Pupil-teacher ratio(headcount basis) in Nepal in 2011?
Make the answer very short. 41.39. What is the difference between the Pupil-teacher ratio(headcount basis) of Sub-Saharan Africa (all income levels) in 2005 and the Pupil-teacher ratio(headcount basis) of Cayman Islands in 2012?
Give a very brief answer. 30.64. What is the difference between the Pupil-teacher ratio(headcount basis) of Sub-Saharan Africa (all income levels) in 2005 and the Pupil-teacher ratio(headcount basis) of Malawi in 2012?
Provide a succinct answer. -30.14. What is the difference between the Pupil-teacher ratio(headcount basis) in Sub-Saharan Africa (all income levels) in 2005 and the Pupil-teacher ratio(headcount basis) in Nepal in 2012?
Your response must be concise. 16.42. What is the difference between the Pupil-teacher ratio(headcount basis) in Cayman Islands in 2005 and the Pupil-teacher ratio(headcount basis) in Malawi in 2012?
Provide a short and direct response. -61.28. What is the difference between the Pupil-teacher ratio(headcount basis) in Cayman Islands in 2005 and the Pupil-teacher ratio(headcount basis) in Nepal in 2012?
Provide a short and direct response. -14.73. What is the difference between the Pupil-teacher ratio(headcount basis) of Malawi in 2005 and the Pupil-teacher ratio(headcount basis) of Nepal in 2012?
Keep it short and to the point. 43.47. What is the difference between the Pupil-teacher ratio(headcount basis) of Sub-Saharan Africa (all income levels) in 2007 and the Pupil-teacher ratio(headcount basis) of Cayman Islands in 2008?
Provide a short and direct response. 33.62. What is the difference between the Pupil-teacher ratio(headcount basis) in Sub-Saharan Africa (all income levels) in 2007 and the Pupil-teacher ratio(headcount basis) in Malawi in 2008?
Give a very brief answer. -32.69. What is the difference between the Pupil-teacher ratio(headcount basis) in Sub-Saharan Africa (all income levels) in 2007 and the Pupil-teacher ratio(headcount basis) in Nepal in 2008?
Your answer should be very brief. 7.9. What is the difference between the Pupil-teacher ratio(headcount basis) in Cayman Islands in 2007 and the Pupil-teacher ratio(headcount basis) in Malawi in 2008?
Your response must be concise. -67.34. What is the difference between the Pupil-teacher ratio(headcount basis) of Cayman Islands in 2007 and the Pupil-teacher ratio(headcount basis) of Nepal in 2008?
Give a very brief answer. -26.75. What is the difference between the Pupil-teacher ratio(headcount basis) in Malawi in 2007 and the Pupil-teacher ratio(headcount basis) in Nepal in 2008?
Your answer should be compact. 40.31. What is the difference between the Pupil-teacher ratio(headcount basis) of Sub-Saharan Africa (all income levels) in 2007 and the Pupil-teacher ratio(headcount basis) of Cayman Islands in 2011?
Ensure brevity in your answer.  33.64. What is the difference between the Pupil-teacher ratio(headcount basis) in Sub-Saharan Africa (all income levels) in 2007 and the Pupil-teacher ratio(headcount basis) in Malawi in 2011?
Offer a terse response. -30.36. What is the difference between the Pupil-teacher ratio(headcount basis) in Sub-Saharan Africa (all income levels) in 2007 and the Pupil-teacher ratio(headcount basis) in Nepal in 2011?
Make the answer very short. 16.1. What is the difference between the Pupil-teacher ratio(headcount basis) in Cayman Islands in 2007 and the Pupil-teacher ratio(headcount basis) in Malawi in 2011?
Provide a succinct answer. -65.01. What is the difference between the Pupil-teacher ratio(headcount basis) in Cayman Islands in 2007 and the Pupil-teacher ratio(headcount basis) in Nepal in 2011?
Make the answer very short. -18.55. What is the difference between the Pupil-teacher ratio(headcount basis) of Malawi in 2007 and the Pupil-teacher ratio(headcount basis) of Nepal in 2011?
Your response must be concise. 48.51. What is the difference between the Pupil-teacher ratio(headcount basis) in Sub-Saharan Africa (all income levels) in 2007 and the Pupil-teacher ratio(headcount basis) in Cayman Islands in 2012?
Provide a short and direct response. 32.41. What is the difference between the Pupil-teacher ratio(headcount basis) in Sub-Saharan Africa (all income levels) in 2007 and the Pupil-teacher ratio(headcount basis) in Malawi in 2012?
Provide a succinct answer. -28.37. What is the difference between the Pupil-teacher ratio(headcount basis) of Sub-Saharan Africa (all income levels) in 2007 and the Pupil-teacher ratio(headcount basis) of Nepal in 2012?
Provide a short and direct response. 18.18. What is the difference between the Pupil-teacher ratio(headcount basis) of Cayman Islands in 2007 and the Pupil-teacher ratio(headcount basis) of Malawi in 2012?
Provide a succinct answer. -63.02. What is the difference between the Pupil-teacher ratio(headcount basis) of Cayman Islands in 2007 and the Pupil-teacher ratio(headcount basis) of Nepal in 2012?
Your answer should be very brief. -16.47. What is the difference between the Pupil-teacher ratio(headcount basis) in Malawi in 2007 and the Pupil-teacher ratio(headcount basis) in Nepal in 2012?
Your answer should be compact. 50.59. What is the difference between the Pupil-teacher ratio(headcount basis) in Sub-Saharan Africa (all income levels) in 2008 and the Pupil-teacher ratio(headcount basis) in Cayman Islands in 2011?
Give a very brief answer. 33.3. What is the difference between the Pupil-teacher ratio(headcount basis) of Sub-Saharan Africa (all income levels) in 2008 and the Pupil-teacher ratio(headcount basis) of Malawi in 2011?
Your answer should be compact. -30.7. What is the difference between the Pupil-teacher ratio(headcount basis) of Sub-Saharan Africa (all income levels) in 2008 and the Pupil-teacher ratio(headcount basis) of Nepal in 2011?
Give a very brief answer. 15.76. What is the difference between the Pupil-teacher ratio(headcount basis) in Cayman Islands in 2008 and the Pupil-teacher ratio(headcount basis) in Malawi in 2011?
Your answer should be very brief. -63.98. What is the difference between the Pupil-teacher ratio(headcount basis) in Cayman Islands in 2008 and the Pupil-teacher ratio(headcount basis) in Nepal in 2011?
Your answer should be very brief. -17.52. What is the difference between the Pupil-teacher ratio(headcount basis) in Malawi in 2008 and the Pupil-teacher ratio(headcount basis) in Nepal in 2011?
Your answer should be compact. 48.79. What is the difference between the Pupil-teacher ratio(headcount basis) in Sub-Saharan Africa (all income levels) in 2008 and the Pupil-teacher ratio(headcount basis) in Cayman Islands in 2012?
Your answer should be compact. 32.06. What is the difference between the Pupil-teacher ratio(headcount basis) in Sub-Saharan Africa (all income levels) in 2008 and the Pupil-teacher ratio(headcount basis) in Malawi in 2012?
Your response must be concise. -28.71. What is the difference between the Pupil-teacher ratio(headcount basis) in Sub-Saharan Africa (all income levels) in 2008 and the Pupil-teacher ratio(headcount basis) in Nepal in 2012?
Give a very brief answer. 17.84. What is the difference between the Pupil-teacher ratio(headcount basis) of Cayman Islands in 2008 and the Pupil-teacher ratio(headcount basis) of Malawi in 2012?
Your answer should be compact. -62. What is the difference between the Pupil-teacher ratio(headcount basis) of Cayman Islands in 2008 and the Pupil-teacher ratio(headcount basis) of Nepal in 2012?
Make the answer very short. -15.44. What is the difference between the Pupil-teacher ratio(headcount basis) of Malawi in 2008 and the Pupil-teacher ratio(headcount basis) of Nepal in 2012?
Make the answer very short. 50.87. What is the difference between the Pupil-teacher ratio(headcount basis) of Sub-Saharan Africa (all income levels) in 2011 and the Pupil-teacher ratio(headcount basis) of Cayman Islands in 2012?
Give a very brief answer. 29.99. What is the difference between the Pupil-teacher ratio(headcount basis) of Sub-Saharan Africa (all income levels) in 2011 and the Pupil-teacher ratio(headcount basis) of Malawi in 2012?
Keep it short and to the point. -30.79. What is the difference between the Pupil-teacher ratio(headcount basis) of Sub-Saharan Africa (all income levels) in 2011 and the Pupil-teacher ratio(headcount basis) of Nepal in 2012?
Offer a very short reply. 15.77. What is the difference between the Pupil-teacher ratio(headcount basis) in Cayman Islands in 2011 and the Pupil-teacher ratio(headcount basis) in Malawi in 2012?
Your response must be concise. -62.01. What is the difference between the Pupil-teacher ratio(headcount basis) in Cayman Islands in 2011 and the Pupil-teacher ratio(headcount basis) in Nepal in 2012?
Ensure brevity in your answer.  -15.46. What is the difference between the Pupil-teacher ratio(headcount basis) in Malawi in 2011 and the Pupil-teacher ratio(headcount basis) in Nepal in 2012?
Keep it short and to the point. 48.54. What is the average Pupil-teacher ratio(headcount basis) in Sub-Saharan Africa (all income levels) per year?
Offer a very short reply. 43.92. What is the average Pupil-teacher ratio(headcount basis) of Cayman Islands per year?
Keep it short and to the point. 13.14. What is the average Pupil-teacher ratio(headcount basis) in Malawi per year?
Ensure brevity in your answer.  72.87. What is the average Pupil-teacher ratio(headcount basis) of Nepal per year?
Provide a succinct answer. 36.18. In the year 1999, what is the difference between the Pupil-teacher ratio(headcount basis) of Sub-Saharan Africa (all income levels) and Pupil-teacher ratio(headcount basis) of Cayman Islands?
Your response must be concise. 26.66. In the year 1999, what is the difference between the Pupil-teacher ratio(headcount basis) in Sub-Saharan Africa (all income levels) and Pupil-teacher ratio(headcount basis) in Malawi?
Offer a very short reply. -21.11. In the year 1999, what is the difference between the Pupil-teacher ratio(headcount basis) of Sub-Saharan Africa (all income levels) and Pupil-teacher ratio(headcount basis) of Nepal?
Keep it short and to the point. 3.07. In the year 1999, what is the difference between the Pupil-teacher ratio(headcount basis) in Cayman Islands and Pupil-teacher ratio(headcount basis) in Malawi?
Your answer should be compact. -47.76. In the year 1999, what is the difference between the Pupil-teacher ratio(headcount basis) of Cayman Islands and Pupil-teacher ratio(headcount basis) of Nepal?
Keep it short and to the point. -23.59. In the year 1999, what is the difference between the Pupil-teacher ratio(headcount basis) in Malawi and Pupil-teacher ratio(headcount basis) in Nepal?
Make the answer very short. 24.17. In the year 2002, what is the difference between the Pupil-teacher ratio(headcount basis) of Sub-Saharan Africa (all income levels) and Pupil-teacher ratio(headcount basis) of Cayman Islands?
Your answer should be very brief. 29.5. In the year 2002, what is the difference between the Pupil-teacher ratio(headcount basis) of Sub-Saharan Africa (all income levels) and Pupil-teacher ratio(headcount basis) of Malawi?
Provide a short and direct response. -25.6. In the year 2002, what is the difference between the Pupil-teacher ratio(headcount basis) in Sub-Saharan Africa (all income levels) and Pupil-teacher ratio(headcount basis) in Nepal?
Offer a terse response. 4.55. In the year 2002, what is the difference between the Pupil-teacher ratio(headcount basis) of Cayman Islands and Pupil-teacher ratio(headcount basis) of Malawi?
Ensure brevity in your answer.  -55.1. In the year 2002, what is the difference between the Pupil-teacher ratio(headcount basis) in Cayman Islands and Pupil-teacher ratio(headcount basis) in Nepal?
Provide a succinct answer. -24.96. In the year 2002, what is the difference between the Pupil-teacher ratio(headcount basis) of Malawi and Pupil-teacher ratio(headcount basis) of Nepal?
Make the answer very short. 30.15. In the year 2004, what is the difference between the Pupil-teacher ratio(headcount basis) of Sub-Saharan Africa (all income levels) and Pupil-teacher ratio(headcount basis) of Cayman Islands?
Give a very brief answer. 30.51. In the year 2004, what is the difference between the Pupil-teacher ratio(headcount basis) of Sub-Saharan Africa (all income levels) and Pupil-teacher ratio(headcount basis) of Malawi?
Ensure brevity in your answer.  -28.15. In the year 2004, what is the difference between the Pupil-teacher ratio(headcount basis) in Sub-Saharan Africa (all income levels) and Pupil-teacher ratio(headcount basis) in Nepal?
Keep it short and to the point. 8.07. In the year 2004, what is the difference between the Pupil-teacher ratio(headcount basis) of Cayman Islands and Pupil-teacher ratio(headcount basis) of Malawi?
Offer a terse response. -58.66. In the year 2004, what is the difference between the Pupil-teacher ratio(headcount basis) in Cayman Islands and Pupil-teacher ratio(headcount basis) in Nepal?
Provide a succinct answer. -22.44. In the year 2004, what is the difference between the Pupil-teacher ratio(headcount basis) in Malawi and Pupil-teacher ratio(headcount basis) in Nepal?
Offer a terse response. 36.22. In the year 2005, what is the difference between the Pupil-teacher ratio(headcount basis) in Sub-Saharan Africa (all income levels) and Pupil-teacher ratio(headcount basis) in Cayman Islands?
Keep it short and to the point. 31.14. In the year 2005, what is the difference between the Pupil-teacher ratio(headcount basis) of Sub-Saharan Africa (all income levels) and Pupil-teacher ratio(headcount basis) of Malawi?
Your answer should be compact. -27.06. In the year 2005, what is the difference between the Pupil-teacher ratio(headcount basis) in Sub-Saharan Africa (all income levels) and Pupil-teacher ratio(headcount basis) in Nepal?
Give a very brief answer. 4.24. In the year 2005, what is the difference between the Pupil-teacher ratio(headcount basis) in Cayman Islands and Pupil-teacher ratio(headcount basis) in Malawi?
Your response must be concise. -58.2. In the year 2005, what is the difference between the Pupil-teacher ratio(headcount basis) in Cayman Islands and Pupil-teacher ratio(headcount basis) in Nepal?
Offer a very short reply. -26.91. In the year 2005, what is the difference between the Pupil-teacher ratio(headcount basis) of Malawi and Pupil-teacher ratio(headcount basis) of Nepal?
Keep it short and to the point. 31.3. In the year 2007, what is the difference between the Pupil-teacher ratio(headcount basis) in Sub-Saharan Africa (all income levels) and Pupil-teacher ratio(headcount basis) in Cayman Islands?
Provide a short and direct response. 34.65. In the year 2007, what is the difference between the Pupil-teacher ratio(headcount basis) in Sub-Saharan Africa (all income levels) and Pupil-teacher ratio(headcount basis) in Malawi?
Give a very brief answer. -32.41. In the year 2007, what is the difference between the Pupil-teacher ratio(headcount basis) of Sub-Saharan Africa (all income levels) and Pupil-teacher ratio(headcount basis) of Nepal?
Your answer should be compact. 5.7. In the year 2007, what is the difference between the Pupil-teacher ratio(headcount basis) of Cayman Islands and Pupil-teacher ratio(headcount basis) of Malawi?
Your response must be concise. -67.06. In the year 2007, what is the difference between the Pupil-teacher ratio(headcount basis) in Cayman Islands and Pupil-teacher ratio(headcount basis) in Nepal?
Your answer should be very brief. -28.95. In the year 2007, what is the difference between the Pupil-teacher ratio(headcount basis) in Malawi and Pupil-teacher ratio(headcount basis) in Nepal?
Give a very brief answer. 38.1. In the year 2008, what is the difference between the Pupil-teacher ratio(headcount basis) in Sub-Saharan Africa (all income levels) and Pupil-teacher ratio(headcount basis) in Cayman Islands?
Your answer should be compact. 33.28. In the year 2008, what is the difference between the Pupil-teacher ratio(headcount basis) of Sub-Saharan Africa (all income levels) and Pupil-teacher ratio(headcount basis) of Malawi?
Provide a succinct answer. -33.03. In the year 2008, what is the difference between the Pupil-teacher ratio(headcount basis) of Sub-Saharan Africa (all income levels) and Pupil-teacher ratio(headcount basis) of Nepal?
Your answer should be compact. 7.56. In the year 2008, what is the difference between the Pupil-teacher ratio(headcount basis) in Cayman Islands and Pupil-teacher ratio(headcount basis) in Malawi?
Offer a terse response. -66.31. In the year 2008, what is the difference between the Pupil-teacher ratio(headcount basis) in Cayman Islands and Pupil-teacher ratio(headcount basis) in Nepal?
Provide a short and direct response. -25.73. In the year 2008, what is the difference between the Pupil-teacher ratio(headcount basis) in Malawi and Pupil-teacher ratio(headcount basis) in Nepal?
Your answer should be compact. 40.59. In the year 2011, what is the difference between the Pupil-teacher ratio(headcount basis) in Sub-Saharan Africa (all income levels) and Pupil-teacher ratio(headcount basis) in Cayman Islands?
Your answer should be very brief. 31.23. In the year 2011, what is the difference between the Pupil-teacher ratio(headcount basis) of Sub-Saharan Africa (all income levels) and Pupil-teacher ratio(headcount basis) of Malawi?
Your answer should be compact. -32.77. In the year 2011, what is the difference between the Pupil-teacher ratio(headcount basis) of Sub-Saharan Africa (all income levels) and Pupil-teacher ratio(headcount basis) of Nepal?
Offer a terse response. 13.69. In the year 2011, what is the difference between the Pupil-teacher ratio(headcount basis) in Cayman Islands and Pupil-teacher ratio(headcount basis) in Malawi?
Keep it short and to the point. -64. In the year 2011, what is the difference between the Pupil-teacher ratio(headcount basis) in Cayman Islands and Pupil-teacher ratio(headcount basis) in Nepal?
Offer a terse response. -17.54. In the year 2011, what is the difference between the Pupil-teacher ratio(headcount basis) in Malawi and Pupil-teacher ratio(headcount basis) in Nepal?
Your response must be concise. 46.46. In the year 2012, what is the difference between the Pupil-teacher ratio(headcount basis) in Sub-Saharan Africa (all income levels) and Pupil-teacher ratio(headcount basis) in Cayman Islands?
Offer a terse response. 29.29. In the year 2012, what is the difference between the Pupil-teacher ratio(headcount basis) in Sub-Saharan Africa (all income levels) and Pupil-teacher ratio(headcount basis) in Malawi?
Offer a terse response. -31.49. In the year 2012, what is the difference between the Pupil-teacher ratio(headcount basis) of Sub-Saharan Africa (all income levels) and Pupil-teacher ratio(headcount basis) of Nepal?
Keep it short and to the point. 15.07. In the year 2012, what is the difference between the Pupil-teacher ratio(headcount basis) of Cayman Islands and Pupil-teacher ratio(headcount basis) of Malawi?
Keep it short and to the point. -60.78. In the year 2012, what is the difference between the Pupil-teacher ratio(headcount basis) of Cayman Islands and Pupil-teacher ratio(headcount basis) of Nepal?
Offer a very short reply. -14.22. In the year 2012, what is the difference between the Pupil-teacher ratio(headcount basis) of Malawi and Pupil-teacher ratio(headcount basis) of Nepal?
Your answer should be compact. 46.55. What is the ratio of the Pupil-teacher ratio(headcount basis) of Sub-Saharan Africa (all income levels) in 1999 to that in 2002?
Offer a terse response. 0.95. What is the ratio of the Pupil-teacher ratio(headcount basis) in Cayman Islands in 1999 to that in 2002?
Offer a very short reply. 1.04. What is the ratio of the Pupil-teacher ratio(headcount basis) in Malawi in 1999 to that in 2002?
Keep it short and to the point. 0.9. What is the ratio of the Pupil-teacher ratio(headcount basis) in Nepal in 1999 to that in 2002?
Ensure brevity in your answer.  0.98. What is the ratio of the Pupil-teacher ratio(headcount basis) in Sub-Saharan Africa (all income levels) in 1999 to that in 2004?
Offer a very short reply. 0.96. What is the ratio of the Pupil-teacher ratio(headcount basis) in Cayman Islands in 1999 to that in 2004?
Your answer should be very brief. 1.15. What is the ratio of the Pupil-teacher ratio(headcount basis) in Malawi in 1999 to that in 2004?
Make the answer very short. 0.88. What is the ratio of the Pupil-teacher ratio(headcount basis) in Nepal in 1999 to that in 2004?
Make the answer very short. 1.09. What is the ratio of the Pupil-teacher ratio(headcount basis) in Sub-Saharan Africa (all income levels) in 1999 to that in 2005?
Offer a terse response. 0.96. What is the ratio of the Pupil-teacher ratio(headcount basis) of Cayman Islands in 1999 to that in 2005?
Provide a succinct answer. 1.21. What is the ratio of the Pupil-teacher ratio(headcount basis) of Malawi in 1999 to that in 2005?
Make the answer very short. 0.89. What is the ratio of the Pupil-teacher ratio(headcount basis) of Nepal in 1999 to that in 2005?
Give a very brief answer. 0.98. What is the ratio of the Pupil-teacher ratio(headcount basis) in Sub-Saharan Africa (all income levels) in 1999 to that in 2007?
Provide a short and direct response. 0.92. What is the ratio of the Pupil-teacher ratio(headcount basis) of Cayman Islands in 1999 to that in 2007?
Keep it short and to the point. 1.4. What is the ratio of the Pupil-teacher ratio(headcount basis) in Malawi in 1999 to that in 2007?
Your answer should be compact. 0.81. What is the ratio of the Pupil-teacher ratio(headcount basis) in Nepal in 1999 to that in 2007?
Your answer should be very brief. 0.98. What is the ratio of the Pupil-teacher ratio(headcount basis) of Sub-Saharan Africa (all income levels) in 1999 to that in 2008?
Offer a terse response. 0.93. What is the ratio of the Pupil-teacher ratio(headcount basis) of Cayman Islands in 1999 to that in 2008?
Provide a short and direct response. 1.28. What is the ratio of the Pupil-teacher ratio(headcount basis) of Malawi in 1999 to that in 2008?
Provide a succinct answer. 0.81. What is the ratio of the Pupil-teacher ratio(headcount basis) of Nepal in 1999 to that in 2008?
Keep it short and to the point. 1.03. What is the ratio of the Pupil-teacher ratio(headcount basis) in Sub-Saharan Africa (all income levels) in 1999 to that in 2011?
Your answer should be very brief. 0.97. What is the ratio of the Pupil-teacher ratio(headcount basis) in Cayman Islands in 1999 to that in 2011?
Ensure brevity in your answer.  1.28. What is the ratio of the Pupil-teacher ratio(headcount basis) in Malawi in 1999 to that in 2011?
Keep it short and to the point. 0.83. What is the ratio of the Pupil-teacher ratio(headcount basis) of Nepal in 1999 to that in 2011?
Your response must be concise. 1.32. What is the ratio of the Pupil-teacher ratio(headcount basis) of Cayman Islands in 1999 to that in 2012?
Your answer should be very brief. 1.16. What is the ratio of the Pupil-teacher ratio(headcount basis) of Malawi in 1999 to that in 2012?
Your answer should be compact. 0.85. What is the ratio of the Pupil-teacher ratio(headcount basis) in Nepal in 1999 to that in 2012?
Your answer should be compact. 1.42. What is the ratio of the Pupil-teacher ratio(headcount basis) in Sub-Saharan Africa (all income levels) in 2002 to that in 2004?
Ensure brevity in your answer.  1.01. What is the ratio of the Pupil-teacher ratio(headcount basis) in Cayman Islands in 2002 to that in 2004?
Make the answer very short. 1.11. What is the ratio of the Pupil-teacher ratio(headcount basis) in Malawi in 2002 to that in 2004?
Offer a very short reply. 0.97. What is the ratio of the Pupil-teacher ratio(headcount basis) of Nepal in 2002 to that in 2004?
Your response must be concise. 1.11. What is the ratio of the Pupil-teacher ratio(headcount basis) of Sub-Saharan Africa (all income levels) in 2002 to that in 2005?
Offer a terse response. 1.01. What is the ratio of the Pupil-teacher ratio(headcount basis) in Cayman Islands in 2002 to that in 2005?
Make the answer very short. 1.16. What is the ratio of the Pupil-teacher ratio(headcount basis) of Malawi in 2002 to that in 2005?
Offer a terse response. 0.99. What is the ratio of the Pupil-teacher ratio(headcount basis) of Sub-Saharan Africa (all income levels) in 2002 to that in 2007?
Offer a very short reply. 0.97. What is the ratio of the Pupil-teacher ratio(headcount basis) of Cayman Islands in 2002 to that in 2007?
Your response must be concise. 1.35. What is the ratio of the Pupil-teacher ratio(headcount basis) of Malawi in 2002 to that in 2007?
Keep it short and to the point. 0.9. What is the ratio of the Pupil-teacher ratio(headcount basis) in Sub-Saharan Africa (all income levels) in 2002 to that in 2008?
Make the answer very short. 0.98. What is the ratio of the Pupil-teacher ratio(headcount basis) in Cayman Islands in 2002 to that in 2008?
Ensure brevity in your answer.  1.23. What is the ratio of the Pupil-teacher ratio(headcount basis) in Malawi in 2002 to that in 2008?
Give a very brief answer. 0.89. What is the ratio of the Pupil-teacher ratio(headcount basis) of Nepal in 2002 to that in 2008?
Provide a short and direct response. 1.05. What is the ratio of the Pupil-teacher ratio(headcount basis) in Sub-Saharan Africa (all income levels) in 2002 to that in 2011?
Your response must be concise. 1.03. What is the ratio of the Pupil-teacher ratio(headcount basis) of Cayman Islands in 2002 to that in 2011?
Offer a terse response. 1.23. What is the ratio of the Pupil-teacher ratio(headcount basis) of Malawi in 2002 to that in 2011?
Your answer should be very brief. 0.92. What is the ratio of the Pupil-teacher ratio(headcount basis) of Nepal in 2002 to that in 2011?
Your answer should be compact. 1.35. What is the ratio of the Pupil-teacher ratio(headcount basis) in Sub-Saharan Africa (all income levels) in 2002 to that in 2012?
Offer a terse response. 1.04. What is the ratio of the Pupil-teacher ratio(headcount basis) in Cayman Islands in 2002 to that in 2012?
Provide a succinct answer. 1.12. What is the ratio of the Pupil-teacher ratio(headcount basis) in Malawi in 2002 to that in 2012?
Provide a succinct answer. 0.94. What is the ratio of the Pupil-teacher ratio(headcount basis) of Nepal in 2002 to that in 2012?
Offer a terse response. 1.45. What is the ratio of the Pupil-teacher ratio(headcount basis) of Sub-Saharan Africa (all income levels) in 2004 to that in 2005?
Your response must be concise. 1. What is the ratio of the Pupil-teacher ratio(headcount basis) of Cayman Islands in 2004 to that in 2005?
Offer a terse response. 1.05. What is the ratio of the Pupil-teacher ratio(headcount basis) of Malawi in 2004 to that in 2005?
Make the answer very short. 1.01. What is the ratio of the Pupil-teacher ratio(headcount basis) in Nepal in 2004 to that in 2005?
Make the answer very short. 0.9. What is the ratio of the Pupil-teacher ratio(headcount basis) of Sub-Saharan Africa (all income levels) in 2004 to that in 2007?
Make the answer very short. 0.96. What is the ratio of the Pupil-teacher ratio(headcount basis) in Cayman Islands in 2004 to that in 2007?
Provide a short and direct response. 1.21. What is the ratio of the Pupil-teacher ratio(headcount basis) in Malawi in 2004 to that in 2007?
Provide a short and direct response. 0.92. What is the ratio of the Pupil-teacher ratio(headcount basis) in Nepal in 2004 to that in 2007?
Give a very brief answer. 0.9. What is the ratio of the Pupil-teacher ratio(headcount basis) of Sub-Saharan Africa (all income levels) in 2004 to that in 2008?
Provide a succinct answer. 0.97. What is the ratio of the Pupil-teacher ratio(headcount basis) in Cayman Islands in 2004 to that in 2008?
Your answer should be very brief. 1.11. What is the ratio of the Pupil-teacher ratio(headcount basis) in Malawi in 2004 to that in 2008?
Your answer should be very brief. 0.92. What is the ratio of the Pupil-teacher ratio(headcount basis) in Nepal in 2004 to that in 2008?
Your answer should be compact. 0.95. What is the ratio of the Pupil-teacher ratio(headcount basis) in Sub-Saharan Africa (all income levels) in 2004 to that in 2011?
Your response must be concise. 1.01. What is the ratio of the Pupil-teacher ratio(headcount basis) of Cayman Islands in 2004 to that in 2011?
Give a very brief answer. 1.11. What is the ratio of the Pupil-teacher ratio(headcount basis) in Malawi in 2004 to that in 2011?
Offer a terse response. 0.95. What is the ratio of the Pupil-teacher ratio(headcount basis) of Nepal in 2004 to that in 2011?
Give a very brief answer. 1.21. What is the ratio of the Pupil-teacher ratio(headcount basis) of Sub-Saharan Africa (all income levels) in 2004 to that in 2012?
Provide a short and direct response. 1.03. What is the ratio of the Pupil-teacher ratio(headcount basis) of Malawi in 2004 to that in 2012?
Provide a succinct answer. 0.97. What is the ratio of the Pupil-teacher ratio(headcount basis) in Nepal in 2004 to that in 2012?
Ensure brevity in your answer.  1.3. What is the ratio of the Pupil-teacher ratio(headcount basis) in Sub-Saharan Africa (all income levels) in 2005 to that in 2007?
Keep it short and to the point. 0.96. What is the ratio of the Pupil-teacher ratio(headcount basis) of Cayman Islands in 2005 to that in 2007?
Give a very brief answer. 1.16. What is the ratio of the Pupil-teacher ratio(headcount basis) in Malawi in 2005 to that in 2007?
Ensure brevity in your answer.  0.91. What is the ratio of the Pupil-teacher ratio(headcount basis) in Sub-Saharan Africa (all income levels) in 2005 to that in 2008?
Make the answer very short. 0.97. What is the ratio of the Pupil-teacher ratio(headcount basis) in Cayman Islands in 2005 to that in 2008?
Give a very brief answer. 1.06. What is the ratio of the Pupil-teacher ratio(headcount basis) in Malawi in 2005 to that in 2008?
Give a very brief answer. 0.91. What is the ratio of the Pupil-teacher ratio(headcount basis) of Nepal in 2005 to that in 2008?
Your response must be concise. 1.05. What is the ratio of the Pupil-teacher ratio(headcount basis) in Sub-Saharan Africa (all income levels) in 2005 to that in 2011?
Provide a succinct answer. 1.01. What is the ratio of the Pupil-teacher ratio(headcount basis) of Cayman Islands in 2005 to that in 2011?
Give a very brief answer. 1.06. What is the ratio of the Pupil-teacher ratio(headcount basis) of Malawi in 2005 to that in 2011?
Keep it short and to the point. 0.93. What is the ratio of the Pupil-teacher ratio(headcount basis) in Nepal in 2005 to that in 2011?
Give a very brief answer. 1.34. What is the ratio of the Pupil-teacher ratio(headcount basis) of Sub-Saharan Africa (all income levels) in 2005 to that in 2012?
Offer a terse response. 1.03. What is the ratio of the Pupil-teacher ratio(headcount basis) in Cayman Islands in 2005 to that in 2012?
Your answer should be very brief. 0.96. What is the ratio of the Pupil-teacher ratio(headcount basis) in Malawi in 2005 to that in 2012?
Provide a succinct answer. 0.96. What is the ratio of the Pupil-teacher ratio(headcount basis) in Nepal in 2005 to that in 2012?
Offer a terse response. 1.44. What is the ratio of the Pupil-teacher ratio(headcount basis) in Sub-Saharan Africa (all income levels) in 2007 to that in 2008?
Offer a terse response. 1.01. What is the ratio of the Pupil-teacher ratio(headcount basis) of Cayman Islands in 2007 to that in 2008?
Your response must be concise. 0.92. What is the ratio of the Pupil-teacher ratio(headcount basis) in Malawi in 2007 to that in 2008?
Offer a very short reply. 1. What is the ratio of the Pupil-teacher ratio(headcount basis) in Nepal in 2007 to that in 2008?
Offer a terse response. 1.06. What is the ratio of the Pupil-teacher ratio(headcount basis) of Sub-Saharan Africa (all income levels) in 2007 to that in 2011?
Make the answer very short. 1.06. What is the ratio of the Pupil-teacher ratio(headcount basis) in Cayman Islands in 2007 to that in 2011?
Offer a very short reply. 0.92. What is the ratio of the Pupil-teacher ratio(headcount basis) in Malawi in 2007 to that in 2011?
Give a very brief answer. 1.03. What is the ratio of the Pupil-teacher ratio(headcount basis) of Nepal in 2007 to that in 2011?
Make the answer very short. 1.35. What is the ratio of the Pupil-teacher ratio(headcount basis) of Sub-Saharan Africa (all income levels) in 2007 to that in 2012?
Give a very brief answer. 1.07. What is the ratio of the Pupil-teacher ratio(headcount basis) in Cayman Islands in 2007 to that in 2012?
Give a very brief answer. 0.83. What is the ratio of the Pupil-teacher ratio(headcount basis) in Malawi in 2007 to that in 2012?
Offer a terse response. 1.05. What is the ratio of the Pupil-teacher ratio(headcount basis) of Nepal in 2007 to that in 2012?
Give a very brief answer. 1.45. What is the ratio of the Pupil-teacher ratio(headcount basis) in Sub-Saharan Africa (all income levels) in 2008 to that in 2011?
Give a very brief answer. 1.05. What is the ratio of the Pupil-teacher ratio(headcount basis) in Cayman Islands in 2008 to that in 2011?
Provide a short and direct response. 1. What is the ratio of the Pupil-teacher ratio(headcount basis) in Malawi in 2008 to that in 2011?
Your answer should be very brief. 1.03. What is the ratio of the Pupil-teacher ratio(headcount basis) of Nepal in 2008 to that in 2011?
Your answer should be compact. 1.28. What is the ratio of the Pupil-teacher ratio(headcount basis) in Sub-Saharan Africa (all income levels) in 2008 to that in 2012?
Make the answer very short. 1.07. What is the ratio of the Pupil-teacher ratio(headcount basis) in Cayman Islands in 2008 to that in 2012?
Make the answer very short. 0.91. What is the ratio of the Pupil-teacher ratio(headcount basis) in Malawi in 2008 to that in 2012?
Give a very brief answer. 1.06. What is the ratio of the Pupil-teacher ratio(headcount basis) of Nepal in 2008 to that in 2012?
Offer a terse response. 1.37. What is the ratio of the Pupil-teacher ratio(headcount basis) in Sub-Saharan Africa (all income levels) in 2011 to that in 2012?
Make the answer very short. 1.02. What is the ratio of the Pupil-teacher ratio(headcount basis) in Cayman Islands in 2011 to that in 2012?
Your answer should be very brief. 0.91. What is the ratio of the Pupil-teacher ratio(headcount basis) in Malawi in 2011 to that in 2012?
Offer a very short reply. 1.03. What is the ratio of the Pupil-teacher ratio(headcount basis) in Nepal in 2011 to that in 2012?
Offer a very short reply. 1.08. What is the difference between the highest and the second highest Pupil-teacher ratio(headcount basis) in Sub-Saharan Africa (all income levels)?
Give a very brief answer. 0.34. What is the difference between the highest and the second highest Pupil-teacher ratio(headcount basis) of Cayman Islands?
Offer a terse response. 0.55. What is the difference between the highest and the second highest Pupil-teacher ratio(headcount basis) of Malawi?
Offer a very short reply. 0.28. What is the difference between the highest and the second highest Pupil-teacher ratio(headcount basis) of Nepal?
Give a very brief answer. 0.15. What is the difference between the highest and the lowest Pupil-teacher ratio(headcount basis) of Sub-Saharan Africa (all income levels)?
Offer a very short reply. 3.6. What is the difference between the highest and the lowest Pupil-teacher ratio(headcount basis) of Cayman Islands?
Offer a very short reply. 4.4. What is the difference between the highest and the lowest Pupil-teacher ratio(headcount basis) of Malawi?
Your response must be concise. 15.18. What is the difference between the highest and the lowest Pupil-teacher ratio(headcount basis) in Nepal?
Offer a terse response. 12.48. 